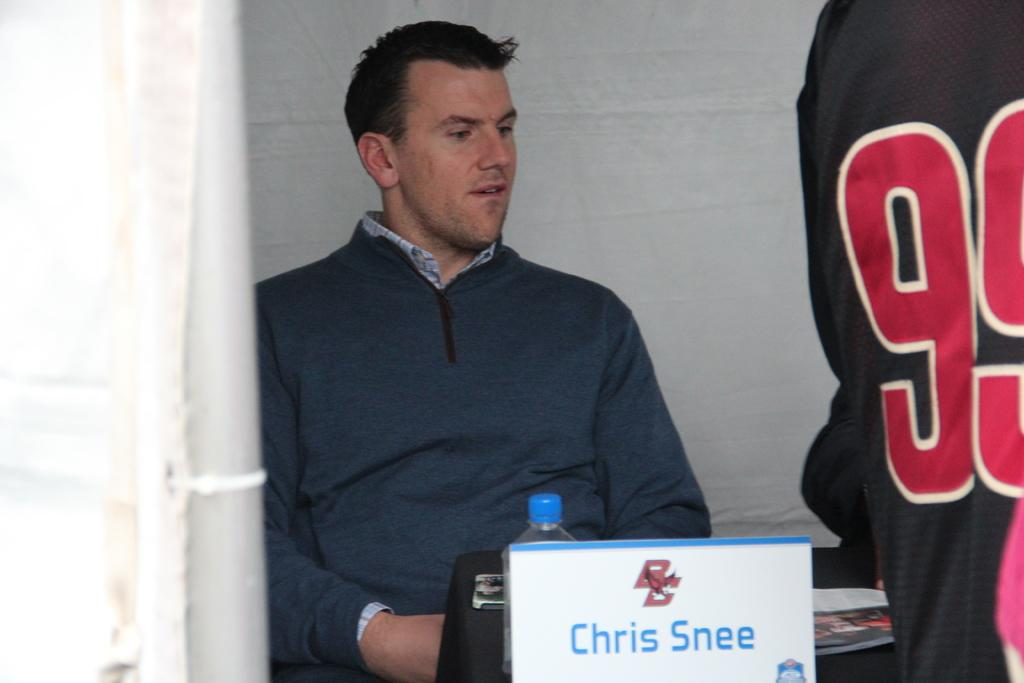<image>
Give a short and clear explanation of the subsequent image. Man named Chris Snee sitting behind a table with a waterbottle. 